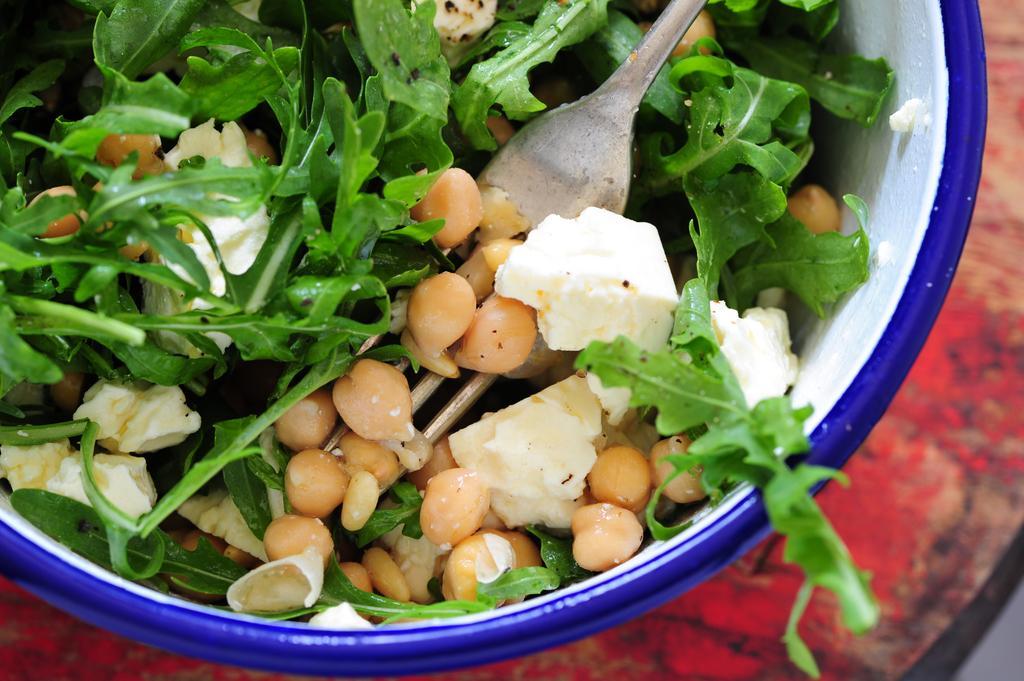Describe this image in one or two sentences. In this image a bowl is kept on the table. Bowl is having spoon and some leafy vegetables and some food in it. 